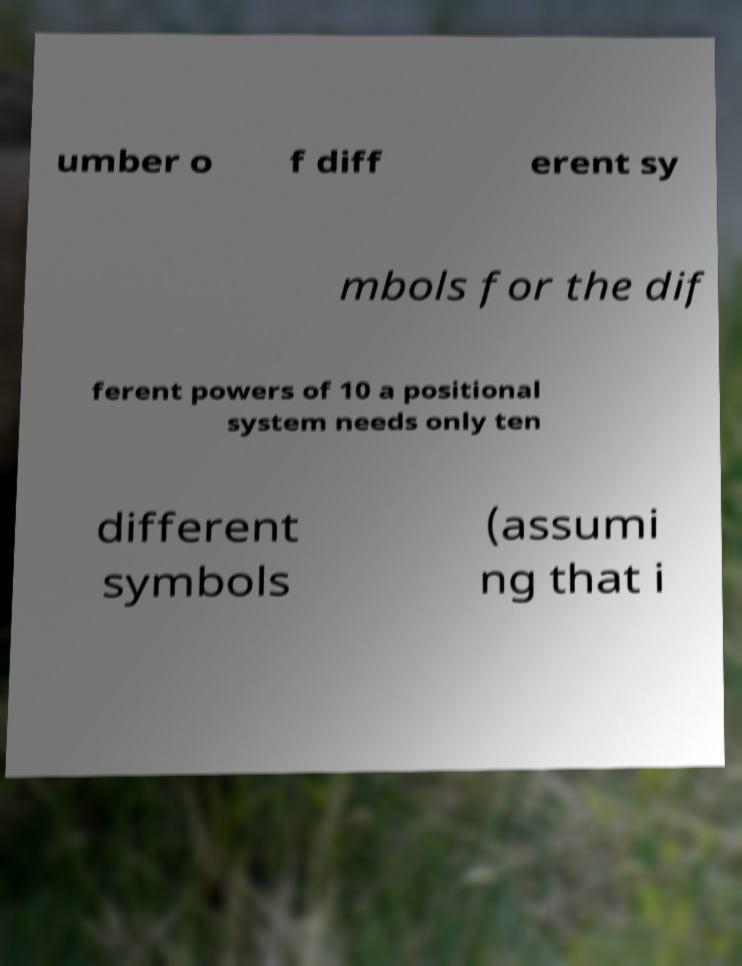Could you extract and type out the text from this image? umber o f diff erent sy mbols for the dif ferent powers of 10 a positional system needs only ten different symbols (assumi ng that i 